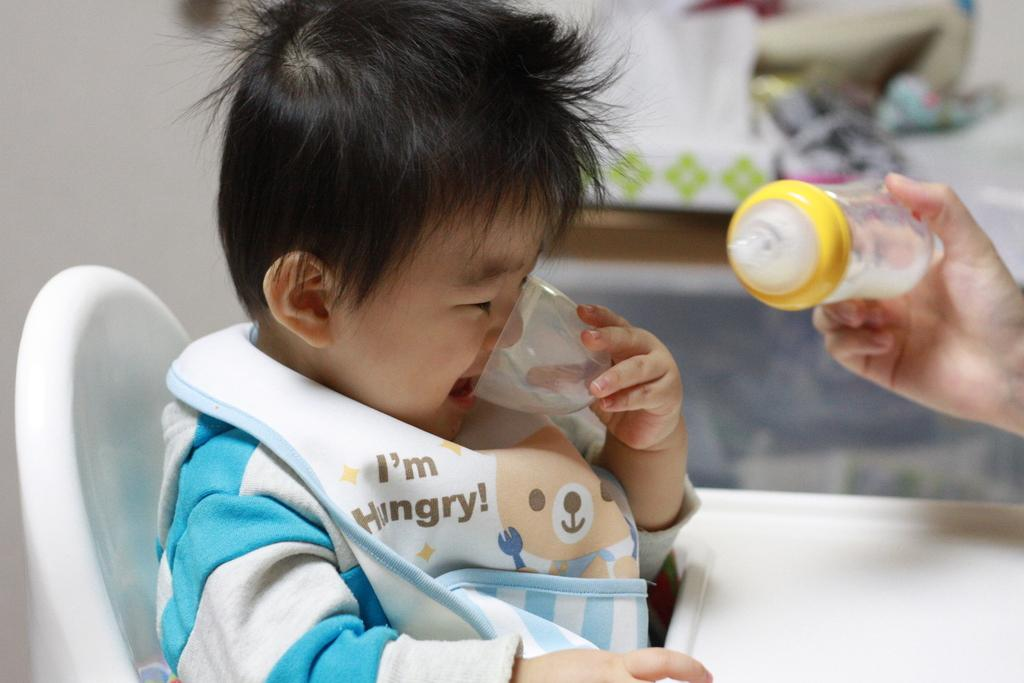<image>
Render a clear and concise summary of the photo. a little boy wearing a bib that says 'i'm hungry!' 